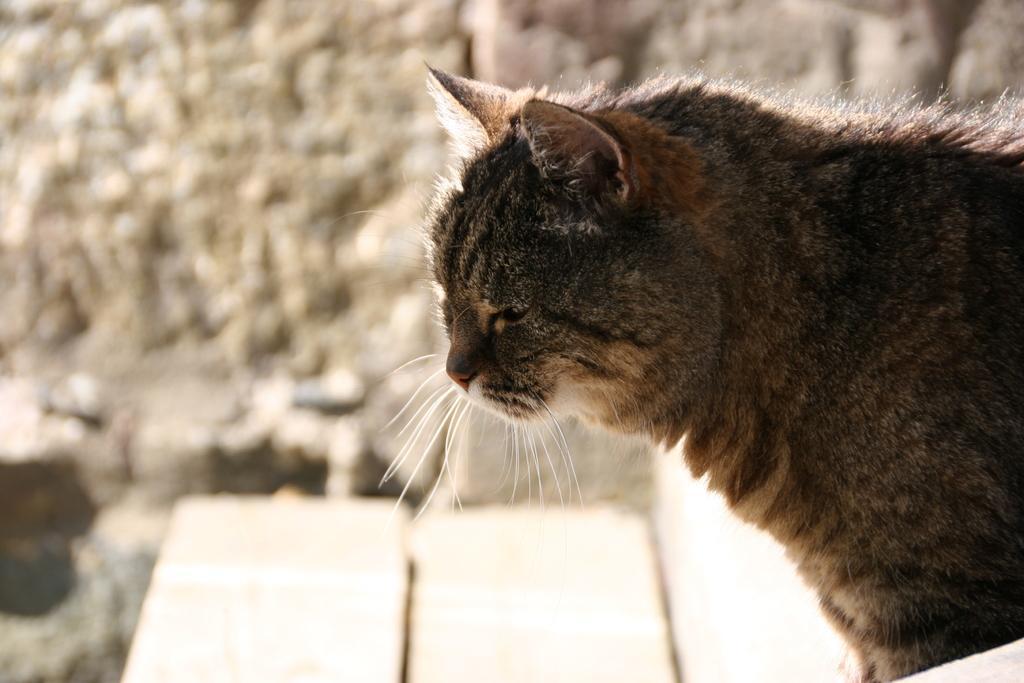Could you give a brief overview of what you see in this image? In this image, we can see a cat. In the background, we can see the wall and few objects. 